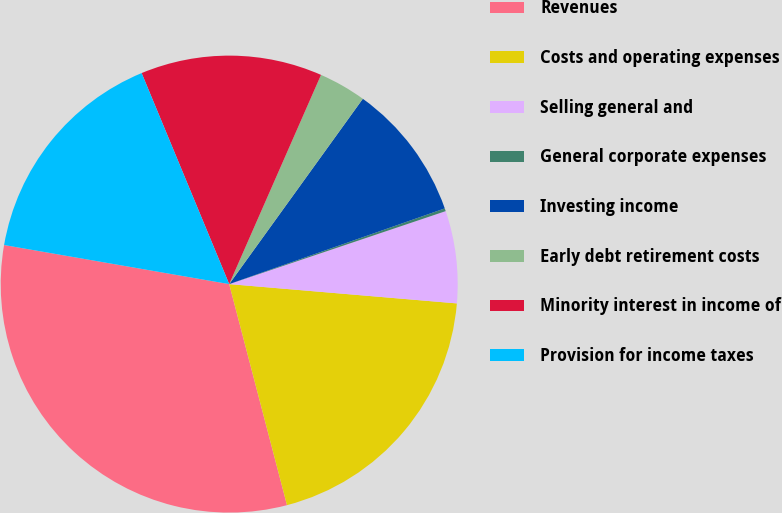Convert chart. <chart><loc_0><loc_0><loc_500><loc_500><pie_chart><fcel>Revenues<fcel>Costs and operating expenses<fcel>Selling general and<fcel>General corporate expenses<fcel>Investing income<fcel>Early debt retirement costs<fcel>Minority interest in income of<fcel>Provision for income taxes<nl><fcel>31.8%<fcel>19.58%<fcel>6.52%<fcel>0.2%<fcel>9.68%<fcel>3.36%<fcel>12.84%<fcel>16.0%<nl></chart> 